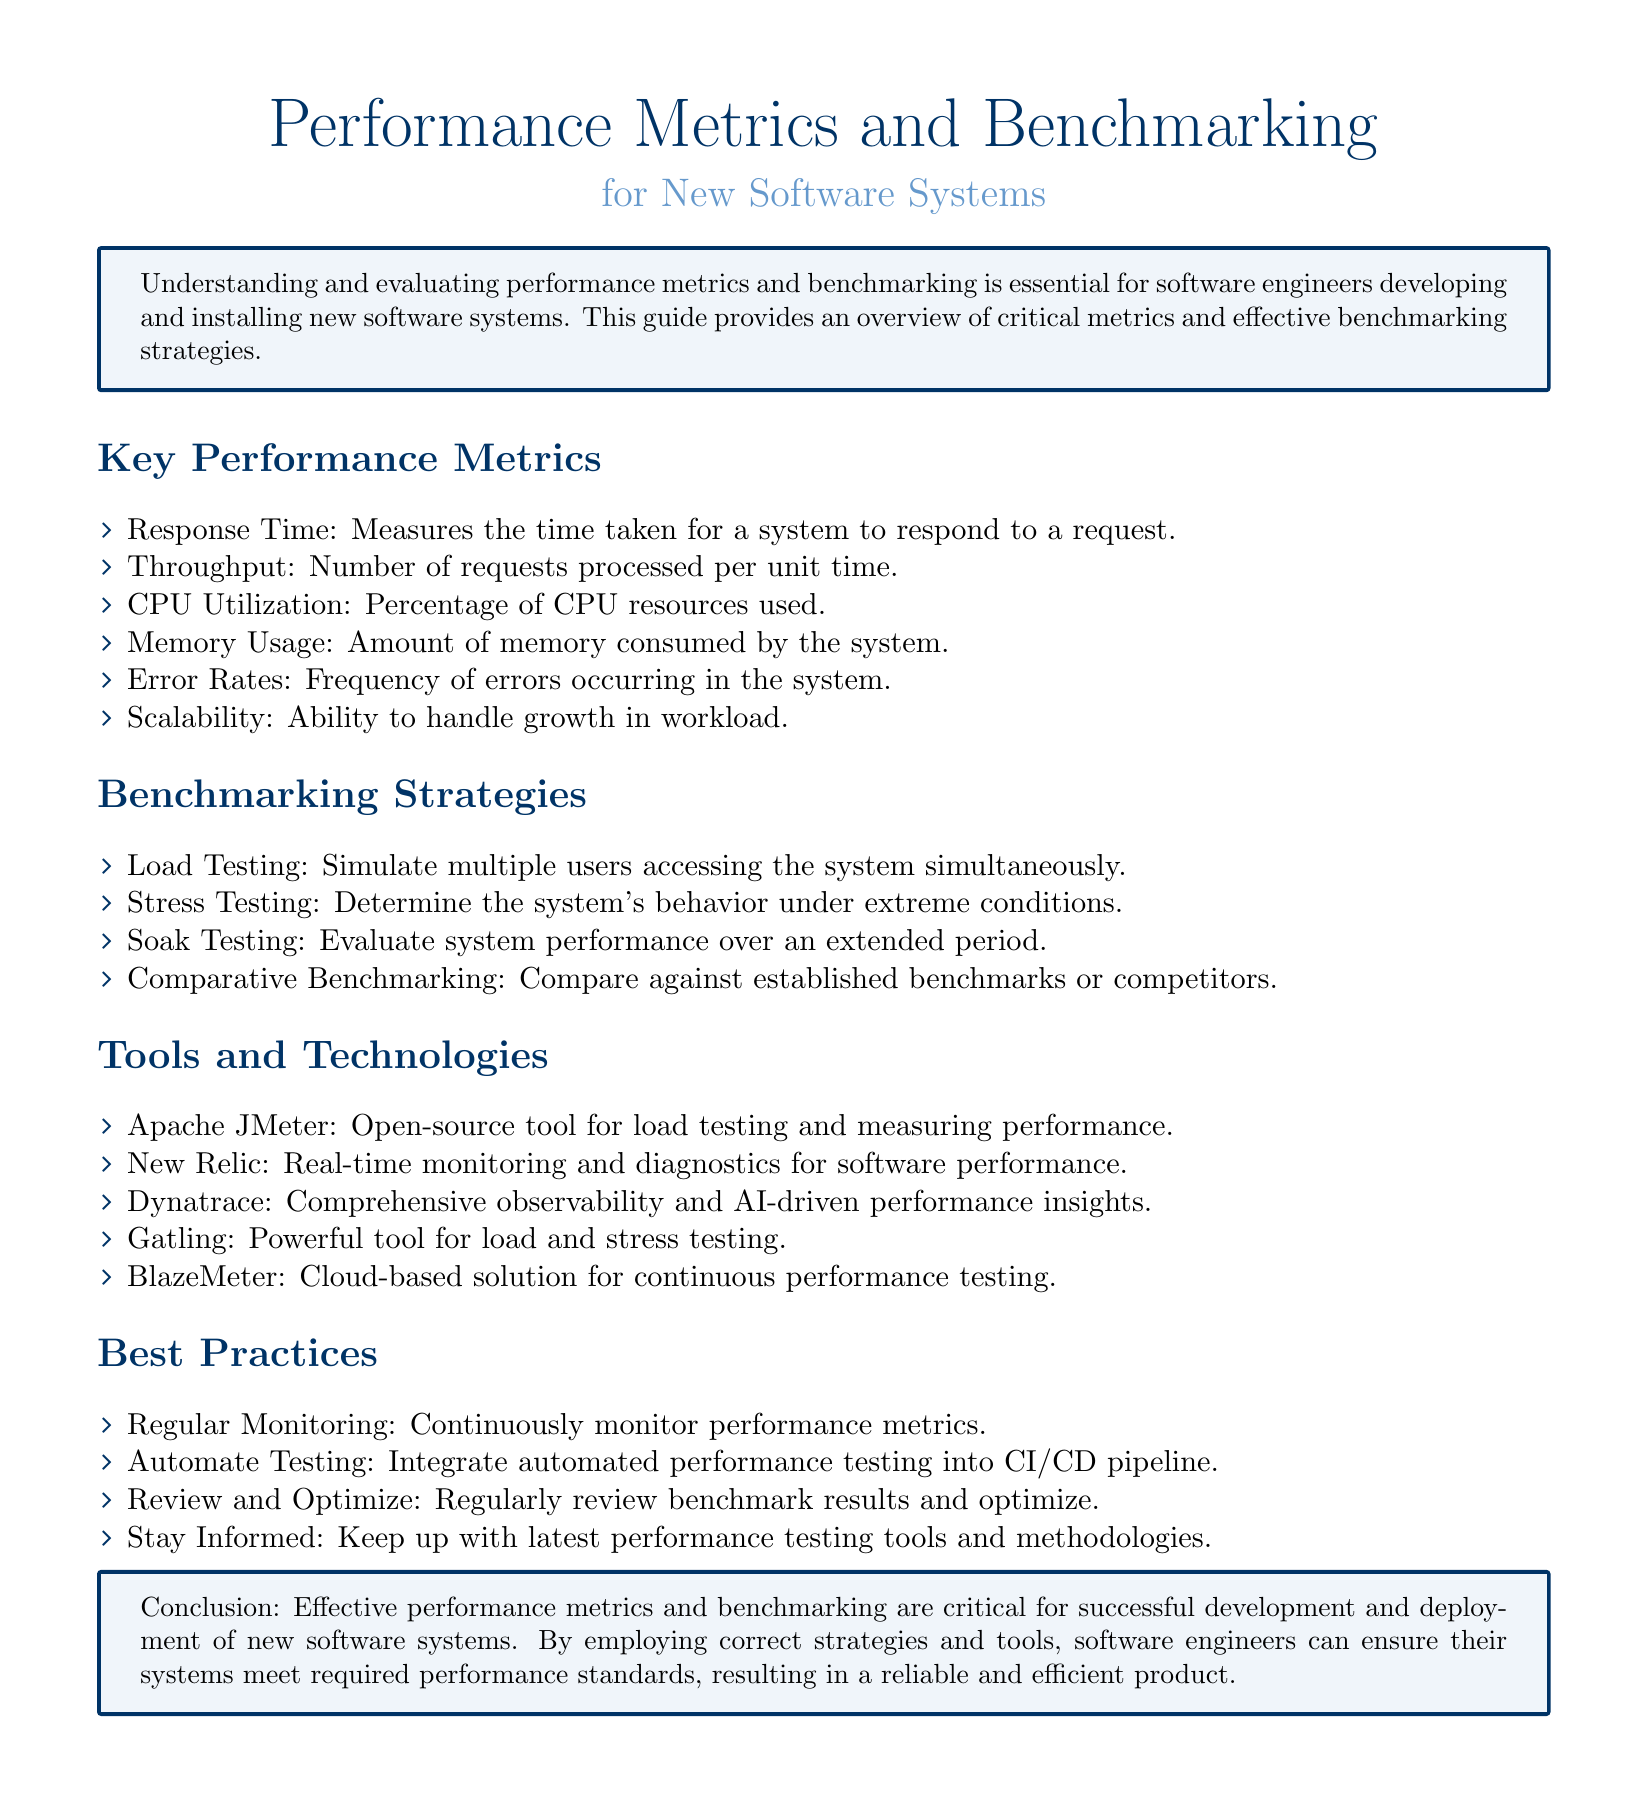What is the definition of Response Time? Response Time measures the time taken for a system to respond to a request.
Answer: Measures the time taken for a system to respond to a request What metric measures the number of requests processed per unit time? Throughput is defined as the number of requests processed per unit time.
Answer: Number of requests processed per unit time Which tool is used for load testing and measuring performance? Apache JMeter is an open-source tool for load testing and measuring performance.
Answer: Apache JMeter What does Scalability refer to in performance metrics? Scalability refers to the ability to handle growth in workload.
Answer: Ability to handle growth in workload What strategy simulates multiple users accessing the system? Load Testing is a strategy that simulates multiple users accessing the system simultaneously.
Answer: Load Testing How often should performance metrics be monitored according to best practices? Regular Monitoring indicates that performance metrics should be continuously monitored.
Answer: Continuously What type of benchmarking compares against established benchmarks or competitors? Comparative Benchmarking is the type of benchmarking that compares against established benchmarks or competitors.
Answer: Comparative Benchmarking What is a recommended practice regarding performance testing in CI/CD pipelines? Automate Testing recommends integrating automated performance testing into the CI/CD pipeline.
Answer: Integrate automated performance testing What does the conclusion state about the importance of performance metrics? The conclusion states that effective performance metrics and benchmarking are critical for successful development and deployment of new software systems.
Answer: Critical for successful development and deployment 